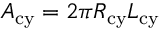<formula> <loc_0><loc_0><loc_500><loc_500>A _ { c y } = 2 \pi R _ { c y } L _ { c y }</formula> 